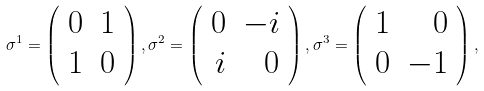Convert formula to latex. <formula><loc_0><loc_0><loc_500><loc_500>\sigma ^ { 1 } = \left ( \begin{array} { r r } 0 & 1 \\ 1 & 0 \end{array} \right ) , \sigma ^ { 2 } = \left ( \begin{array} { r r } 0 & - i \\ i & 0 \end{array} \right ) , \sigma ^ { 3 } = \left ( \begin{array} { r r } 1 & 0 \\ 0 & - 1 \end{array} \right ) ,</formula> 